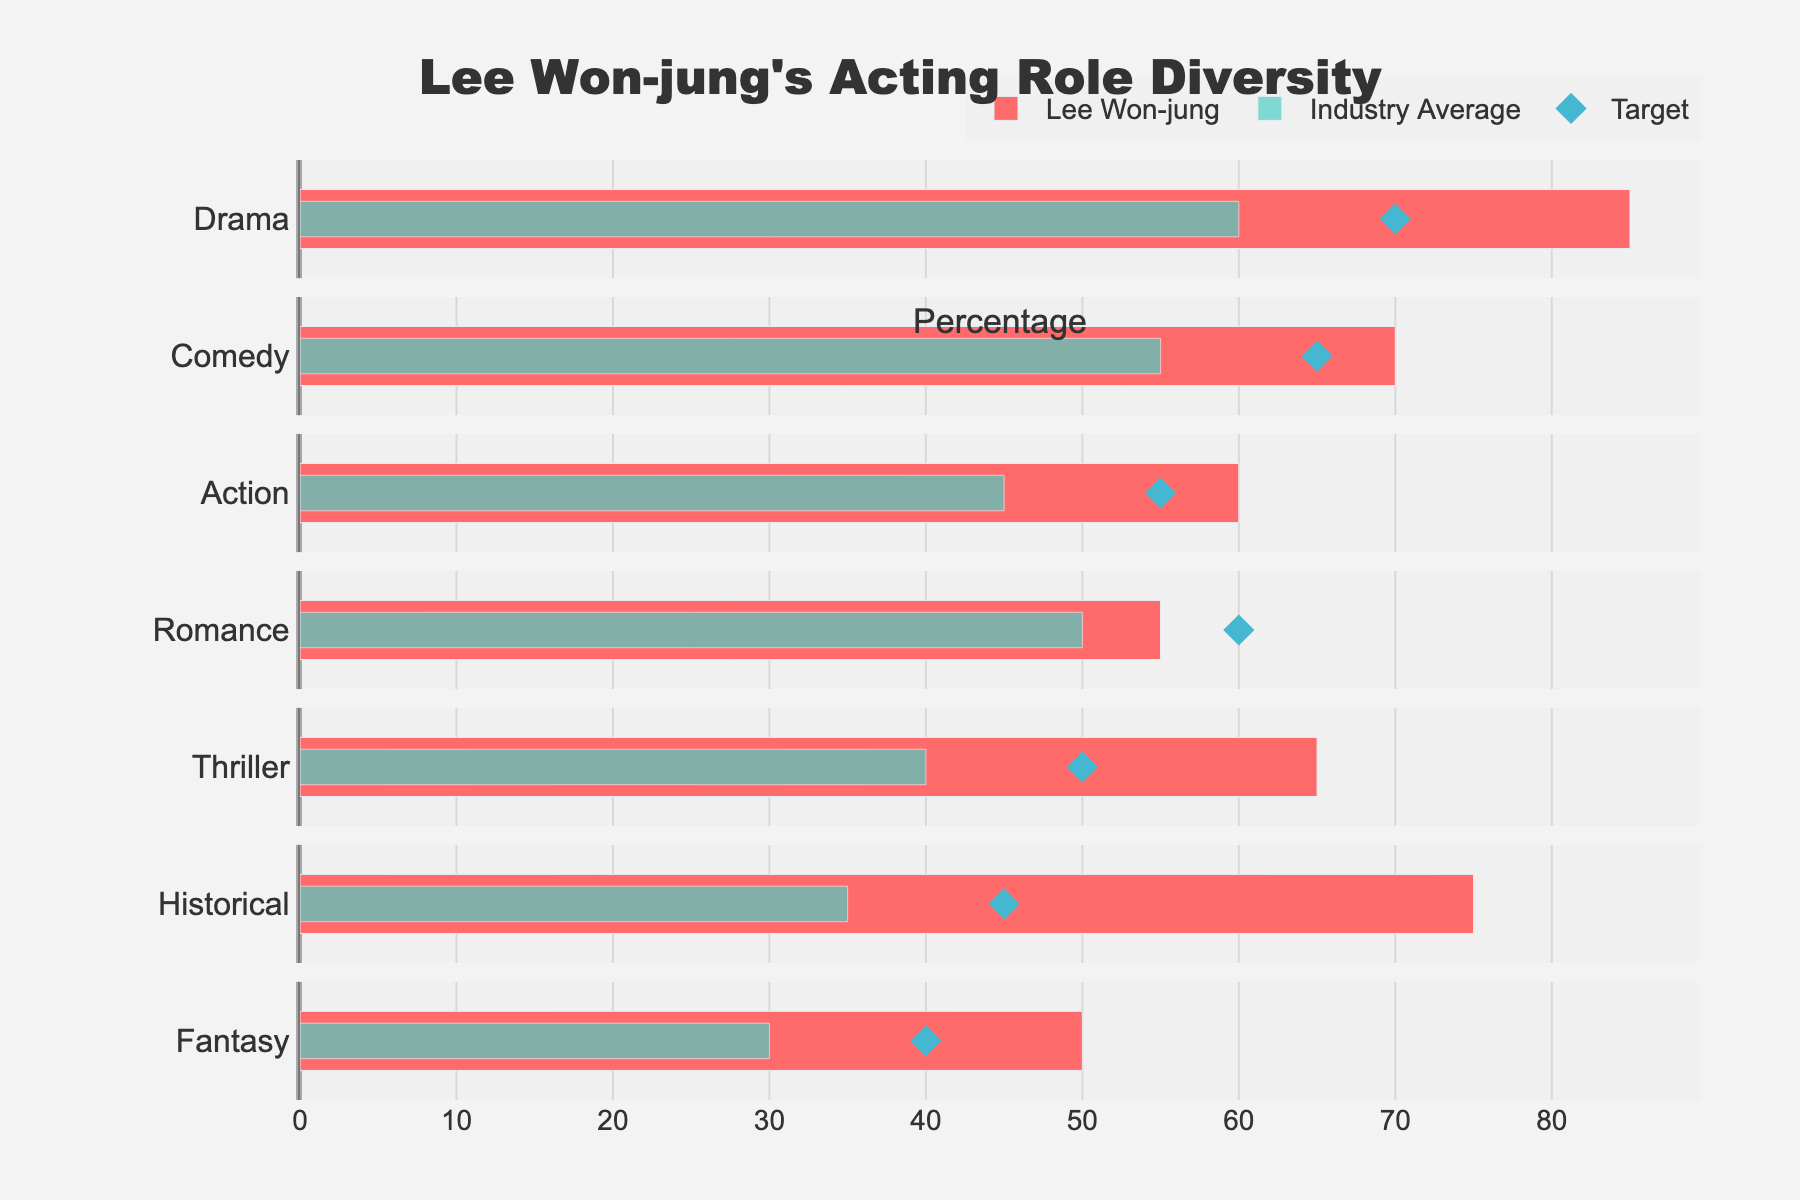What is the title of the figure? The title is displayed at the top of the figure and is styled with a specific font, size, and color for visibility.
Answer: Lee Won-jung's Acting Role Diversity Which genre does Lee Won-jung have the highest percentage of roles in? Look at the bars representing Lee Won-jung's roles across genres and identify the one with the highest value.
Answer: Drama How does Lee Won-jung's percentage of roles in Historical compare to the Industry Average? Compare the heights of the bars for Lee Won-jung and Industry Average in the Historical genre.
Answer: Lee Won-jung's percentage is significantly higher In which genre is the target for Lee Won-jung's role diversity higher than his current percentage? Identify the genres where the target marker is placed further along the x-axis than the bar representing Lee Won-jung's current roles.
Answer: Romance What is the difference between Lee Won-jung's and the Industry Average's percentage for Thriller roles? Subtract the Industry Average's percentage from Lee Won-jung's percentage for Thriller roles.
Answer: 25 What is the overall trend of Lee Won-jung's role distribution compared to the targets? Examine where the targets are placed in relation to Lee Won-jung's bars for all genres.
Answer: Mostly surpasses targets except in Romance and Fantasy In which genre does Lee Won-jung have the smallest lead over the Industry Average? Compare the differences between Lee Won-jung's and Industry Average's percentages across all genres, and identify the smallest difference.
Answer: Romance How many genres have a target percentage of 60 or higher? Count the genres with target markers at 60 or higher on the x-axis.
Answer: Three (Drama, Comedy, Romance) What is the combined percentage of roles in Comedy and Action for the Industry Average? Add the Industry Average percentages for Comedy and Action.
Answer: 100 Which genre has the largest gap between Lee Won-jung's role percentage and the target? Identify the genre with the biggest difference between Lee Won-jung's percentage and the target marker.
Answer: Fantasy 